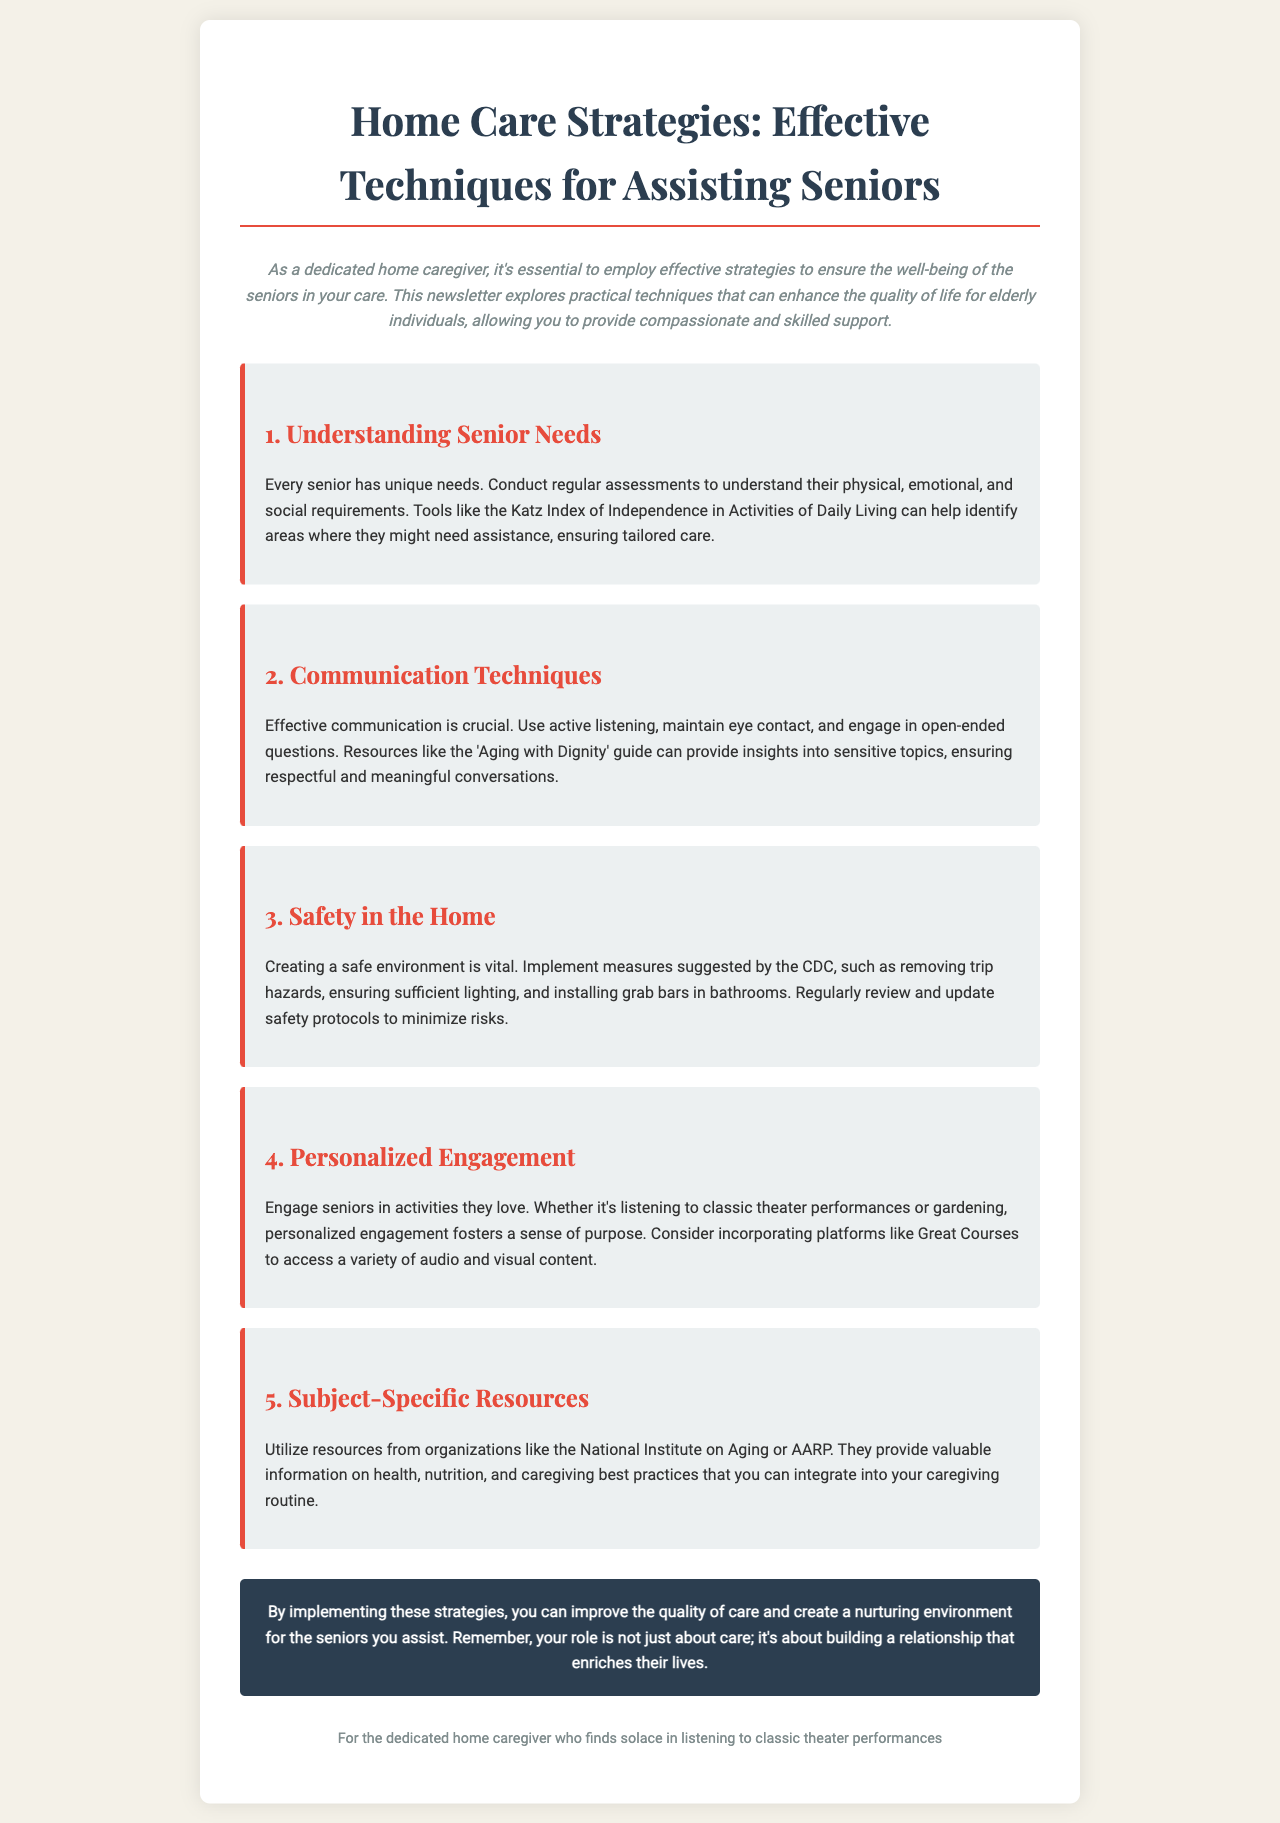what is the title of the newsletter? The title of the newsletter can be found in the header of the document.
Answer: Home Care Strategies: Effective Techniques for Assisting Seniors what is highlighted as a vital part of creating a safe environment? This information is located in the section discussing safety in the home.
Answer: removing trip hazards how can seniors be engaged according to the newsletter? The document suggests activities that can engage seniors, found in the personalized engagement section.
Answer: listening to classic theater performances which organization is mentioned as a resource for caregivers? The newsletter lists organizations that provide resources, specifically named in the subject-specific resources section.
Answer: National Institute on Aging what is the purpose of conducting regular assessments? This can be derived from the understanding senior needs section that outlines the importance of assessments.
Answer: to understand their unique needs what color is the header of the newsletter? This can be determined from the document's styling description.
Answer: #2c3e50 